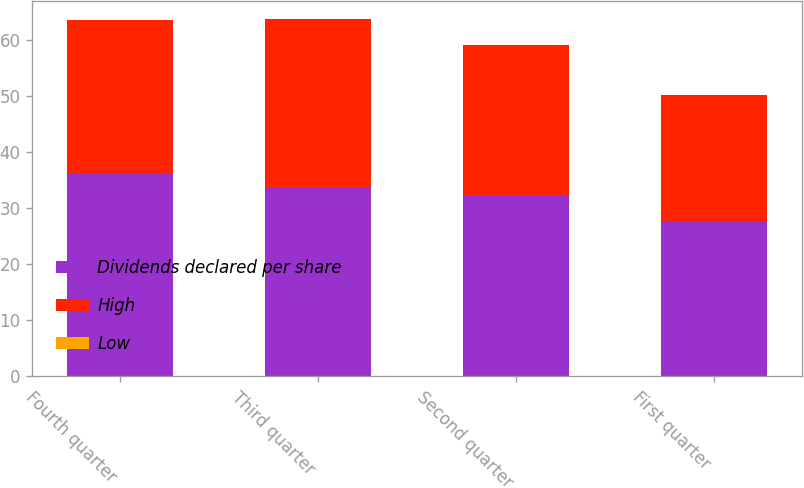Convert chart. <chart><loc_0><loc_0><loc_500><loc_500><stacked_bar_chart><ecel><fcel>Fourth quarter<fcel>Third quarter<fcel>Second quarter<fcel>First quarter<nl><fcel>Dividends declared per share<fcel>36.08<fcel>33.8<fcel>32.41<fcel>27.53<nl><fcel>High<fcel>27.59<fcel>30.07<fcel>26.7<fcel>22.72<nl><fcel>Low<fcel>0.07<fcel>0.04<fcel>0.04<fcel>0.04<nl></chart> 